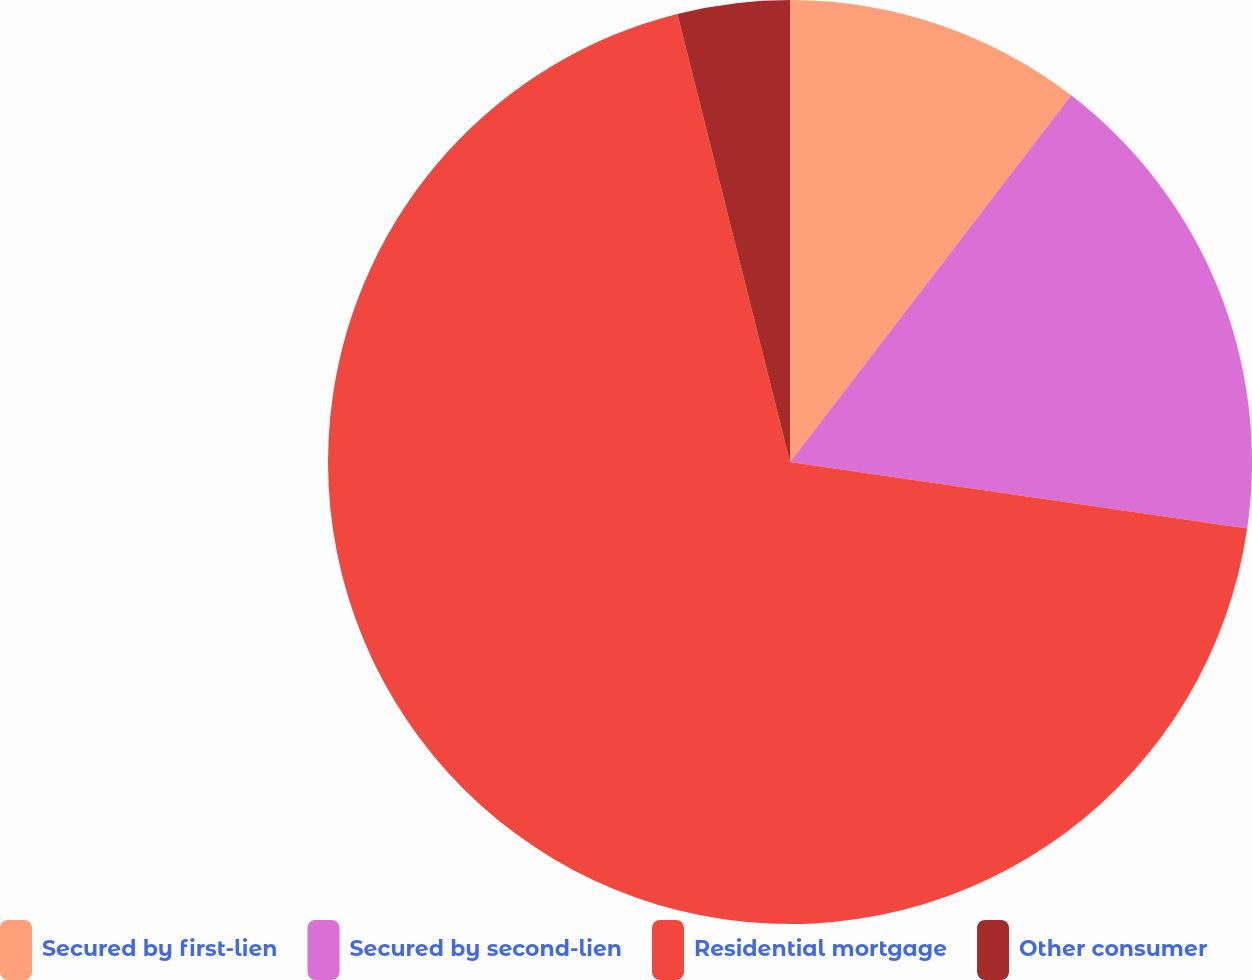Convert chart. <chart><loc_0><loc_0><loc_500><loc_500><pie_chart><fcel>Secured by first-lien<fcel>Secured by second-lien<fcel>Residential mortgage<fcel>Other consumer<nl><fcel>10.41%<fcel>16.89%<fcel>68.78%<fcel>3.92%<nl></chart> 